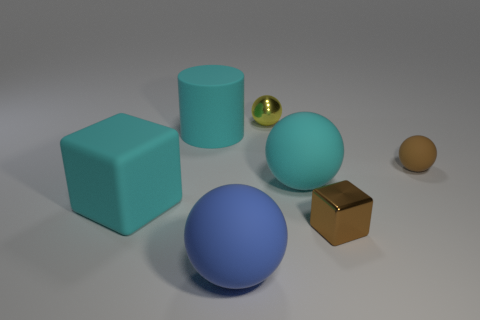Are there any matte spheres on the right side of the block that is on the right side of the big blue matte sphere?
Make the answer very short. Yes. What shape is the tiny brown thing that is made of the same material as the blue thing?
Your answer should be compact. Sphere. Is there anything else of the same color as the tiny shiny sphere?
Provide a short and direct response. No. There is another yellow object that is the same shape as the small matte object; what is it made of?
Your response must be concise. Metal. How many other things are there of the same size as the rubber cylinder?
Your answer should be very brief. 3. There is a matte sphere that is the same color as the small metallic cube; what size is it?
Offer a very short reply. Small. Do the cyan rubber object that is to the right of the small shiny sphere and the tiny brown metal object have the same shape?
Ensure brevity in your answer.  No. How many other objects are there of the same shape as the small brown metallic object?
Provide a short and direct response. 1. There is a cyan object right of the large blue thing; what shape is it?
Provide a short and direct response. Sphere. Is there a small yellow sphere that has the same material as the blue thing?
Give a very brief answer. No. 